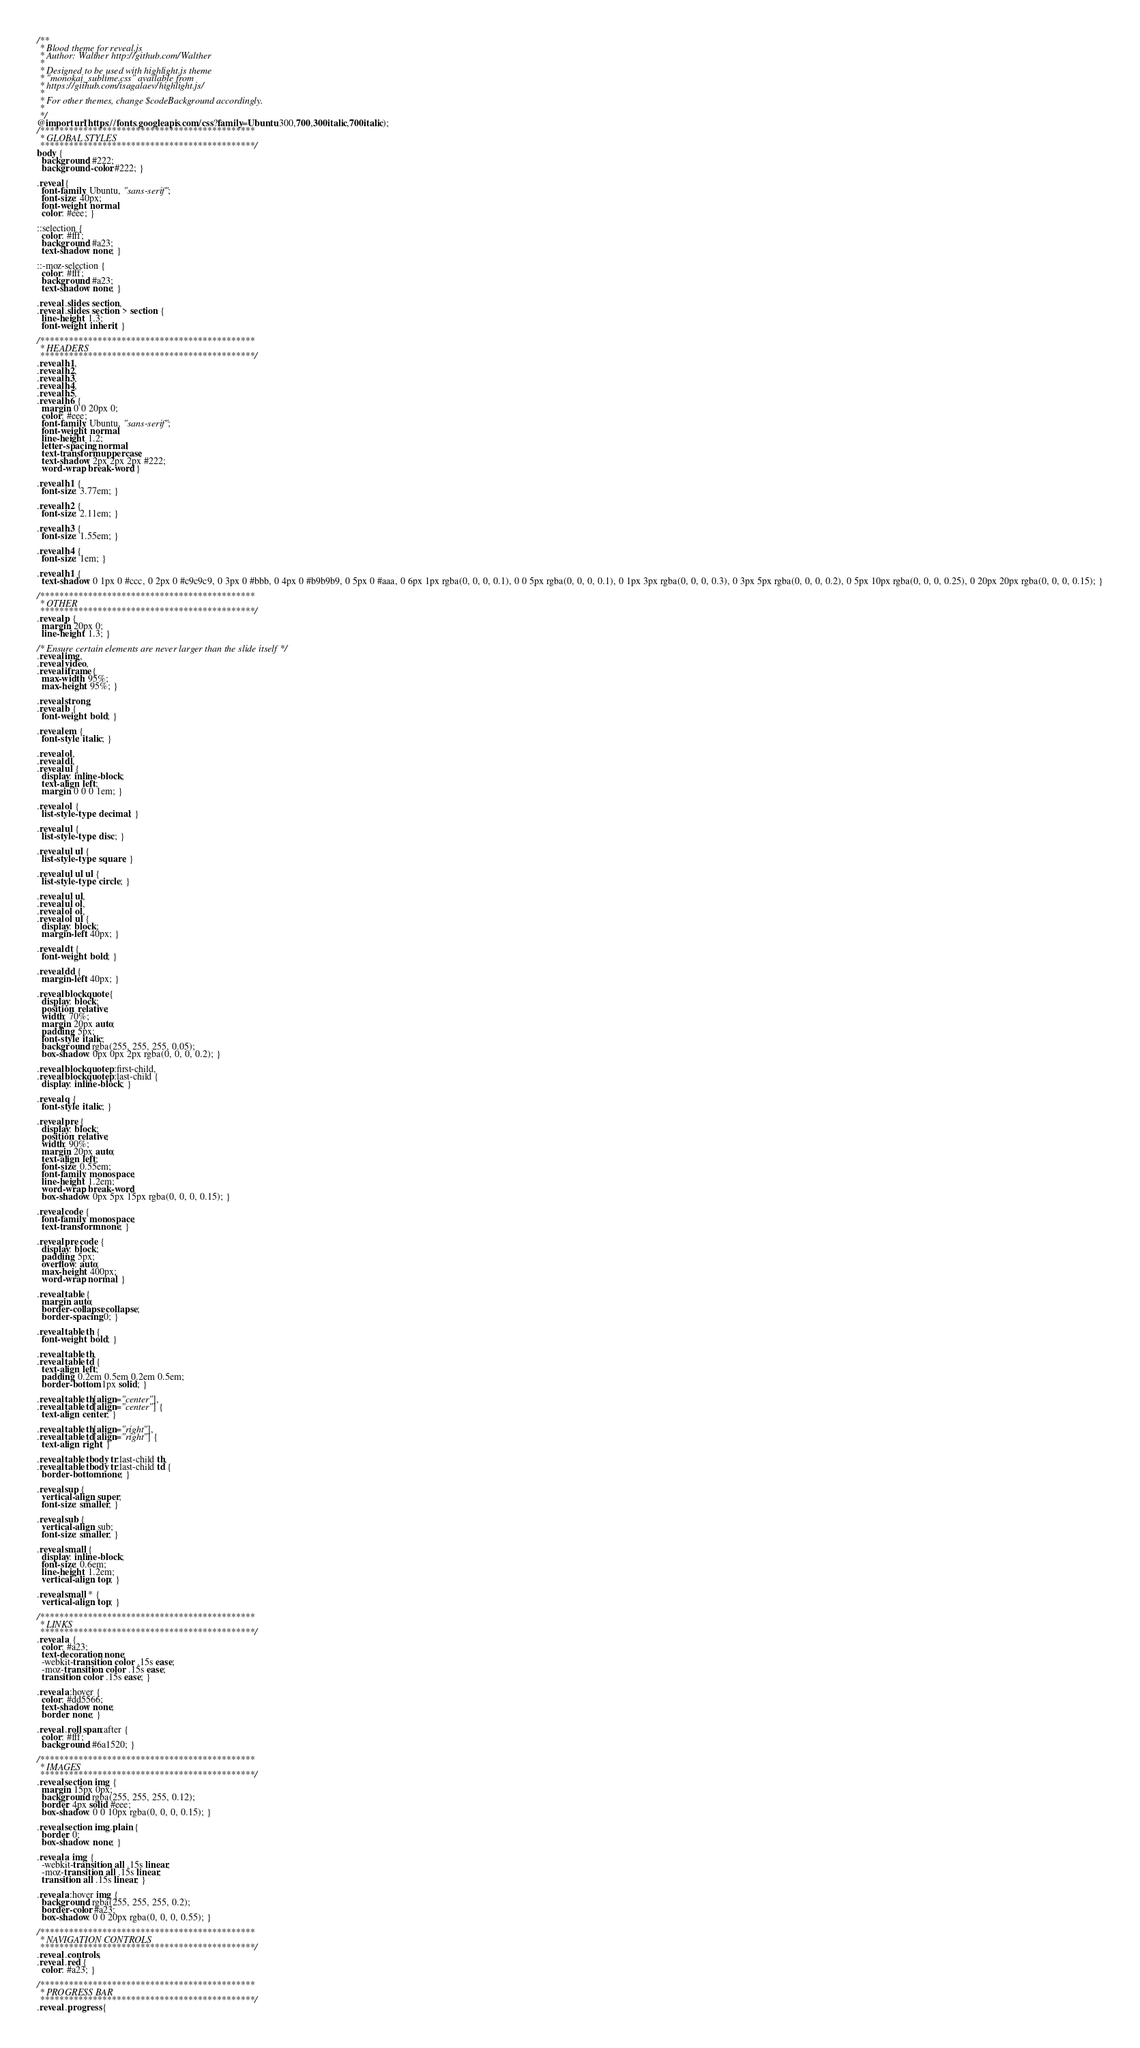Convert code to text. <code><loc_0><loc_0><loc_500><loc_500><_CSS_>/**
 * Blood theme for reveal.js
 * Author: Walther http://github.com/Walther
 *
 * Designed to be used with highlight.js theme
 * "monokai_sublime.css" available from
 * https://github.com/isagalaev/highlight.js/
 *
 * For other themes, change $codeBackground accordingly.
 *
 */
@import url(https://fonts.googleapis.com/css?family=Ubuntu:300,700,300italic,700italic);
/*********************************************
 * GLOBAL STYLES
 *********************************************/
body {
  background: #222;
  background-color: #222; }

.reveal {
  font-family: Ubuntu, "sans-serif";
  font-size: 40px;
  font-weight: normal;
  color: #eee; }

::selection {
  color: #fff;
  background: #a23;
  text-shadow: none; }

::-moz-selection {
  color: #fff;
  background: #a23;
  text-shadow: none; }

.reveal .slides section,
.reveal .slides section > section {
  line-height: 1.3;
  font-weight: inherit; }

/*********************************************
 * HEADERS
 *********************************************/
.reveal h1,
.reveal h2,
.reveal h3,
.reveal h4,
.reveal h5,
.reveal h6 {
  margin: 0 0 20px 0;
  color: #eee;
  font-family: Ubuntu, "sans-serif";
  font-weight: normal;
  line-height: 1.2;
  letter-spacing: normal;
  text-transform: uppercase;
  text-shadow: 2px 2px 2px #222;
  word-wrap: break-word; }

.reveal h1 {
  font-size: 3.77em; }

.reveal h2 {
  font-size: 2.11em; }

.reveal h3 {
  font-size: 1.55em; }

.reveal h4 {
  font-size: 1em; }

.reveal h1 {
  text-shadow: 0 1px 0 #ccc, 0 2px 0 #c9c9c9, 0 3px 0 #bbb, 0 4px 0 #b9b9b9, 0 5px 0 #aaa, 0 6px 1px rgba(0, 0, 0, 0.1), 0 0 5px rgba(0, 0, 0, 0.1), 0 1px 3px rgba(0, 0, 0, 0.3), 0 3px 5px rgba(0, 0, 0, 0.2), 0 5px 10px rgba(0, 0, 0, 0.25), 0 20px 20px rgba(0, 0, 0, 0.15); }

/*********************************************
 * OTHER
 *********************************************/
.reveal p {
  margin: 20px 0;
  line-height: 1.3; }

/* Ensure certain elements are never larger than the slide itself */
.reveal img,
.reveal video,
.reveal iframe {
  max-width: 95%;
  max-height: 95%; }

.reveal strong,
.reveal b {
  font-weight: bold; }

.reveal em {
  font-style: italic; }

.reveal ol,
.reveal dl,
.reveal ul {
  display: inline-block;
  text-align: left;
  margin: 0 0 0 1em; }

.reveal ol {
  list-style-type: decimal; }

.reveal ul {
  list-style-type: disc; }

.reveal ul ul {
  list-style-type: square; }

.reveal ul ul ul {
  list-style-type: circle; }

.reveal ul ul,
.reveal ul ol,
.reveal ol ol,
.reveal ol ul {
  display: block;
  margin-left: 40px; }

.reveal dt {
  font-weight: bold; }

.reveal dd {
  margin-left: 40px; }

.reveal blockquote {
  display: block;
  position: relative;
  width: 70%;
  margin: 20px auto;
  padding: 5px;
  font-style: italic;
  background: rgba(255, 255, 255, 0.05);
  box-shadow: 0px 0px 2px rgba(0, 0, 0, 0.2); }

.reveal blockquote p:first-child,
.reveal blockquote p:last-child {
  display: inline-block; }

.reveal q {
  font-style: italic; }

.reveal pre {
  display: block;
  position: relative;
  width: 90%;
  margin: 20px auto;
  text-align: left;
  font-size: 0.55em;
  font-family: monospace;
  line-height: 1.2em;
  word-wrap: break-word;
  box-shadow: 0px 5px 15px rgba(0, 0, 0, 0.15); }

.reveal code {
  font-family: monospace;
  text-transform: none; }

.reveal pre code {
  display: block;
  padding: 5px;
  overflow: auto;
  max-height: 400px;
  word-wrap: normal; }

.reveal table {
  margin: auto;
  border-collapse: collapse;
  border-spacing: 0; }

.reveal table th {
  font-weight: bold; }

.reveal table th,
.reveal table td {
  text-align: left;
  padding: 0.2em 0.5em 0.2em 0.5em;
  border-bottom: 1px solid; }

.reveal table th[align="center"],
.reveal table td[align="center"] {
  text-align: center; }

.reveal table th[align="right"],
.reveal table td[align="right"] {
  text-align: right; }

.reveal table tbody tr:last-child th,
.reveal table tbody tr:last-child td {
  border-bottom: none; }

.reveal sup {
  vertical-align: super;
  font-size: smaller; }

.reveal sub {
  vertical-align: sub;
  font-size: smaller; }

.reveal small {
  display: inline-block;
  font-size: 0.6em;
  line-height: 1.2em;
  vertical-align: top; }

.reveal small * {
  vertical-align: top; }

/*********************************************
 * LINKS
 *********************************************/
.reveal a {
  color: #a23;
  text-decoration: none;
  -webkit-transition: color .15s ease;
  -moz-transition: color .15s ease;
  transition: color .15s ease; }

.reveal a:hover {
  color: #dd5566;
  text-shadow: none;
  border: none; }

.reveal .roll span:after {
  color: #fff;
  background: #6a1520; }

/*********************************************
 * IMAGES
 *********************************************/
.reveal section img {
  margin: 15px 0px;
  background: rgba(255, 255, 255, 0.12);
  border: 4px solid #eee;
  box-shadow: 0 0 10px rgba(0, 0, 0, 0.15); }

.reveal section img.plain {
  border: 0;
  box-shadow: none; }

.reveal a img {
  -webkit-transition: all .15s linear;
  -moz-transition: all .15s linear;
  transition: all .15s linear; }

.reveal a:hover img {
  background: rgba(255, 255, 255, 0.2);
  border-color: #a23;
  box-shadow: 0 0 20px rgba(0, 0, 0, 0.55); }

/*********************************************
 * NAVIGATION CONTROLS
 *********************************************/
.reveal .controls,
.reveal .red {
  color: #a23; }

/*********************************************
 * PROGRESS BAR
 *********************************************/
.reveal .progress {</code> 